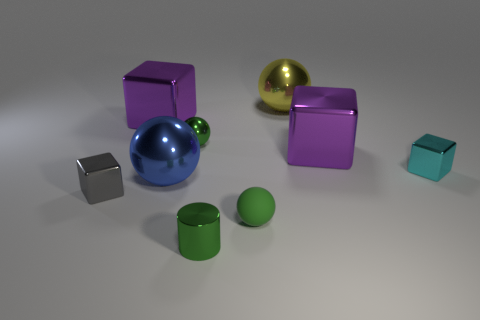Subtract 1 blocks. How many blocks are left? 3 Subtract all cubes. How many objects are left? 5 Add 9 cyan blocks. How many cyan blocks are left? 10 Add 2 large yellow metallic balls. How many large yellow metallic balls exist? 3 Subtract 0 yellow cylinders. How many objects are left? 9 Subtract all brown shiny cylinders. Subtract all rubber objects. How many objects are left? 8 